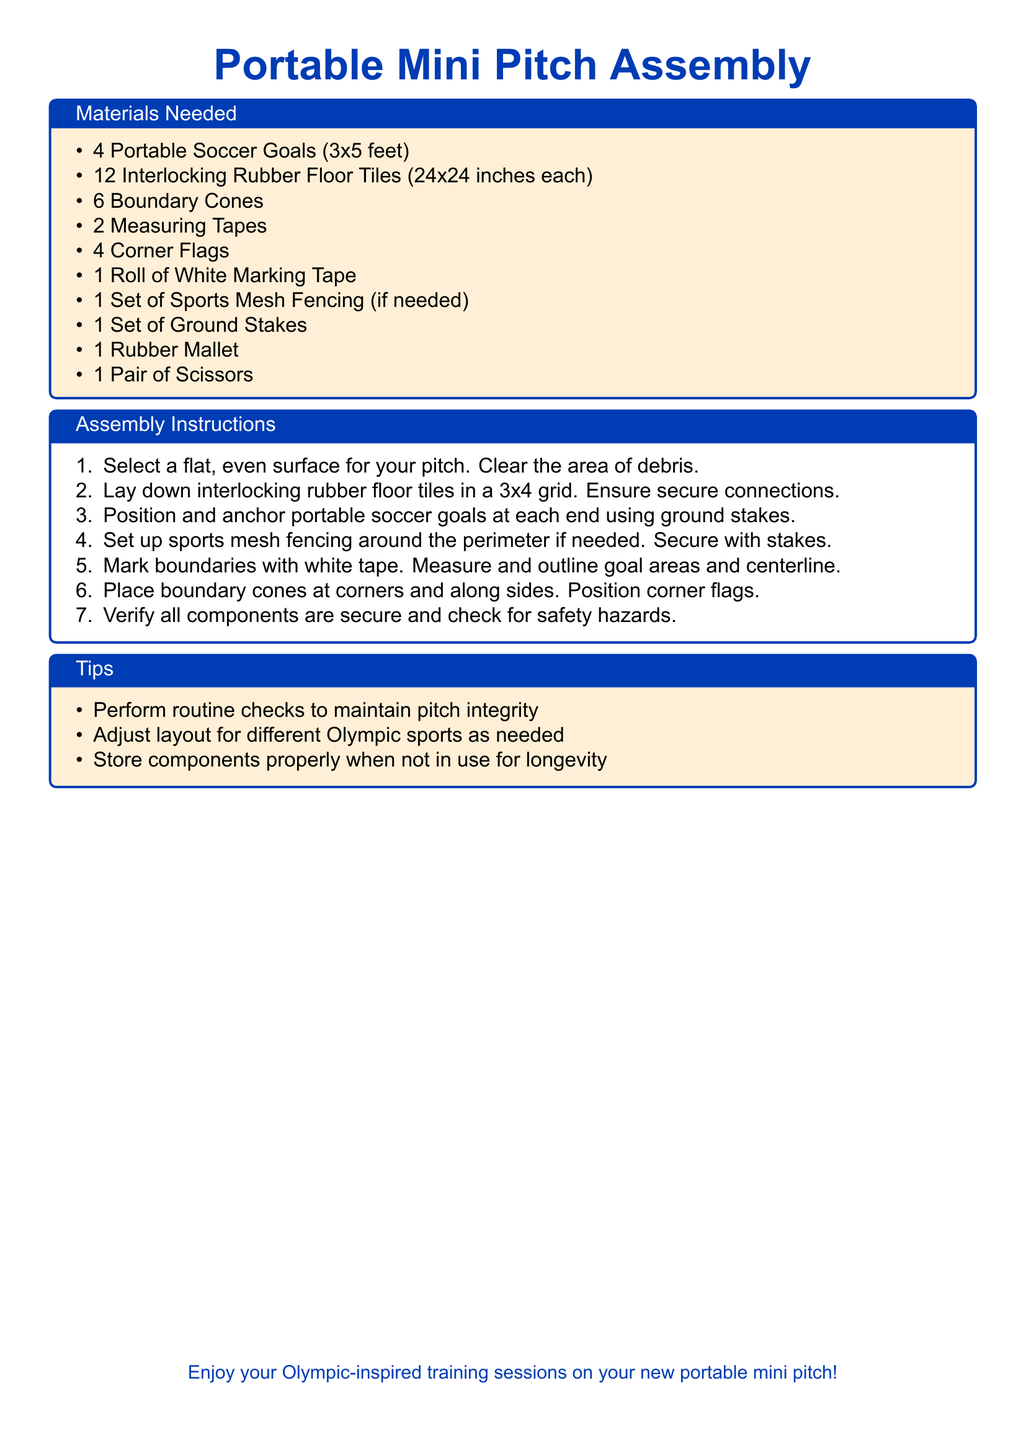What is the size of the portable soccer goals? The size of the portable soccer goals is specified in the materials needed section of the document as 3x5 feet.
Answer: 3x5 feet How many boundary cones are required? The materials needed section lists 6 boundary cones as necessary for assembly.
Answer: 6 What shape is the grid for the rubber floor tiles? The assembly instructions describe laying down the rubber floor tiles in a 3x4 grid pattern.
Answer: 3x4 grid What tool is used to secure the ground stakes? The assembly instructions mention using a rubber mallet to anchor the portable soccer goals with ground stakes.
Answer: Rubber mallet What is the purpose of the white marking tape? The assembly instructions indicate that the white marking tape is used to mark boundaries, goal areas, and centerline of the pitch.
Answer: Mark boundaries Which sports can be practiced on this portable mini pitch? The title and introduction suggest that soccer and track events can be practiced on this pitch, based on the use of soccer goals and layout flexibility for different sports.
Answer: Soccer and track events What should be done with components when not in use? The tips section advises storing components properly when not in use for longevity, hinting at maintenance.
Answer: Store properly How many interlocking rubber floor tiles are needed? The materials needed states that 12 interlocking rubber floor tiles are required for the assembly.
Answer: 12 